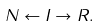<formula> <loc_0><loc_0><loc_500><loc_500>N \gets I \to R .</formula> 